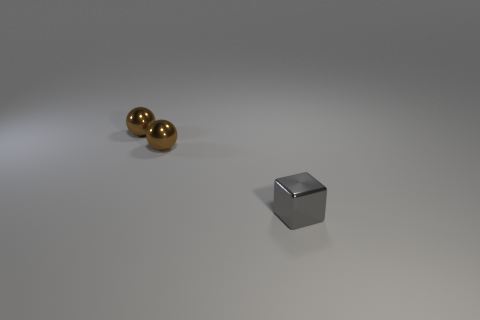Are there any other things of the same color as the small metal cube?
Give a very brief answer. No. Are there any tiny brown metal things?
Your answer should be compact. Yes. Is there a red thing made of the same material as the tiny gray block?
Give a very brief answer. No. The metal block is what color?
Ensure brevity in your answer.  Gray. What number of matte things are either tiny cubes or small green balls?
Your response must be concise. 0. Is there any other thing that is the same shape as the gray metal thing?
Your answer should be compact. No. What number of other objects are the same size as the gray object?
Keep it short and to the point. 2. How many things are brown metallic cubes or small metal things that are behind the tiny gray thing?
Offer a very short reply. 2. What number of brown objects are metallic things or metallic balls?
Give a very brief answer. 2. Are there any gray shiny blocks right of the tiny shiny cube?
Your answer should be very brief. No. 